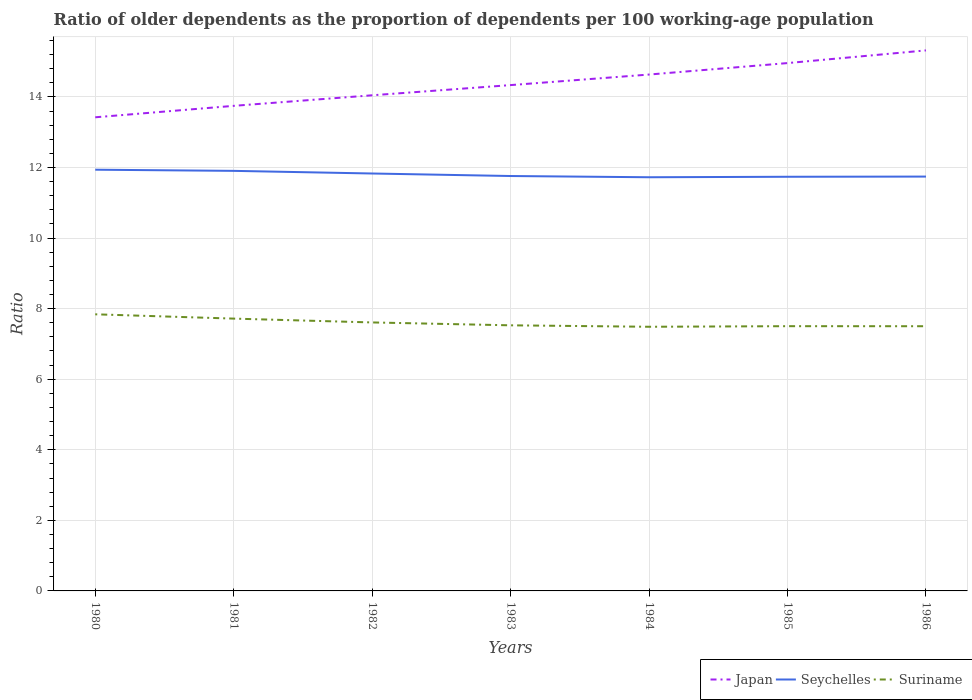Is the number of lines equal to the number of legend labels?
Offer a terse response. Yes. Across all years, what is the maximum age dependency ratio(old) in Japan?
Offer a terse response. 13.42. In which year was the age dependency ratio(old) in Seychelles maximum?
Keep it short and to the point. 1984. What is the total age dependency ratio(old) in Japan in the graph?
Offer a very short reply. -0.68. What is the difference between the highest and the second highest age dependency ratio(old) in Suriname?
Offer a very short reply. 0.35. What is the difference between the highest and the lowest age dependency ratio(old) in Seychelles?
Provide a short and direct response. 3. How many lines are there?
Provide a short and direct response. 3. What is the difference between two consecutive major ticks on the Y-axis?
Provide a short and direct response. 2. Does the graph contain any zero values?
Your response must be concise. No. How are the legend labels stacked?
Make the answer very short. Horizontal. What is the title of the graph?
Your answer should be very brief. Ratio of older dependents as the proportion of dependents per 100 working-age population. Does "Micronesia" appear as one of the legend labels in the graph?
Your answer should be compact. No. What is the label or title of the X-axis?
Provide a succinct answer. Years. What is the label or title of the Y-axis?
Your response must be concise. Ratio. What is the Ratio of Japan in 1980?
Make the answer very short. 13.42. What is the Ratio in Seychelles in 1980?
Your answer should be very brief. 11.94. What is the Ratio in Suriname in 1980?
Your answer should be very brief. 7.84. What is the Ratio in Japan in 1981?
Give a very brief answer. 13.75. What is the Ratio of Seychelles in 1981?
Provide a succinct answer. 11.9. What is the Ratio of Suriname in 1981?
Offer a terse response. 7.72. What is the Ratio in Japan in 1982?
Your response must be concise. 14.05. What is the Ratio of Seychelles in 1982?
Ensure brevity in your answer.  11.83. What is the Ratio of Suriname in 1982?
Offer a very short reply. 7.61. What is the Ratio in Japan in 1983?
Keep it short and to the point. 14.33. What is the Ratio of Seychelles in 1983?
Provide a short and direct response. 11.76. What is the Ratio of Suriname in 1983?
Offer a very short reply. 7.53. What is the Ratio in Japan in 1984?
Give a very brief answer. 14.63. What is the Ratio of Seychelles in 1984?
Your answer should be very brief. 11.72. What is the Ratio in Suriname in 1984?
Provide a short and direct response. 7.49. What is the Ratio of Japan in 1985?
Offer a terse response. 14.96. What is the Ratio in Seychelles in 1985?
Provide a short and direct response. 11.74. What is the Ratio of Suriname in 1985?
Provide a short and direct response. 7.5. What is the Ratio of Japan in 1986?
Offer a terse response. 15.32. What is the Ratio in Seychelles in 1986?
Your response must be concise. 11.74. What is the Ratio of Suriname in 1986?
Offer a very short reply. 7.5. Across all years, what is the maximum Ratio in Japan?
Your answer should be compact. 15.32. Across all years, what is the maximum Ratio of Seychelles?
Give a very brief answer. 11.94. Across all years, what is the maximum Ratio of Suriname?
Keep it short and to the point. 7.84. Across all years, what is the minimum Ratio of Japan?
Your response must be concise. 13.42. Across all years, what is the minimum Ratio in Seychelles?
Provide a succinct answer. 11.72. Across all years, what is the minimum Ratio of Suriname?
Your answer should be compact. 7.49. What is the total Ratio in Japan in the graph?
Give a very brief answer. 100.46. What is the total Ratio of Seychelles in the graph?
Provide a short and direct response. 82.63. What is the total Ratio in Suriname in the graph?
Offer a very short reply. 53.18. What is the difference between the Ratio of Japan in 1980 and that in 1981?
Provide a short and direct response. -0.32. What is the difference between the Ratio in Seychelles in 1980 and that in 1981?
Your response must be concise. 0.03. What is the difference between the Ratio in Suriname in 1980 and that in 1981?
Provide a short and direct response. 0.12. What is the difference between the Ratio of Japan in 1980 and that in 1982?
Your answer should be compact. -0.62. What is the difference between the Ratio of Seychelles in 1980 and that in 1982?
Your answer should be compact. 0.11. What is the difference between the Ratio of Suriname in 1980 and that in 1982?
Your answer should be very brief. 0.23. What is the difference between the Ratio of Japan in 1980 and that in 1983?
Ensure brevity in your answer.  -0.91. What is the difference between the Ratio in Seychelles in 1980 and that in 1983?
Provide a short and direct response. 0.18. What is the difference between the Ratio of Suriname in 1980 and that in 1983?
Offer a terse response. 0.31. What is the difference between the Ratio of Japan in 1980 and that in 1984?
Your response must be concise. -1.21. What is the difference between the Ratio of Seychelles in 1980 and that in 1984?
Provide a short and direct response. 0.21. What is the difference between the Ratio of Suriname in 1980 and that in 1984?
Provide a short and direct response. 0.35. What is the difference between the Ratio in Japan in 1980 and that in 1985?
Make the answer very short. -1.54. What is the difference between the Ratio of Suriname in 1980 and that in 1985?
Your answer should be compact. 0.34. What is the difference between the Ratio in Japan in 1980 and that in 1986?
Offer a terse response. -1.9. What is the difference between the Ratio of Seychelles in 1980 and that in 1986?
Provide a succinct answer. 0.19. What is the difference between the Ratio of Suriname in 1980 and that in 1986?
Offer a terse response. 0.34. What is the difference between the Ratio in Japan in 1981 and that in 1982?
Your response must be concise. -0.3. What is the difference between the Ratio of Seychelles in 1981 and that in 1982?
Offer a terse response. 0.07. What is the difference between the Ratio of Suriname in 1981 and that in 1982?
Provide a short and direct response. 0.11. What is the difference between the Ratio in Japan in 1981 and that in 1983?
Your answer should be very brief. -0.59. What is the difference between the Ratio in Seychelles in 1981 and that in 1983?
Offer a very short reply. 0.15. What is the difference between the Ratio of Suriname in 1981 and that in 1983?
Ensure brevity in your answer.  0.19. What is the difference between the Ratio of Japan in 1981 and that in 1984?
Provide a short and direct response. -0.89. What is the difference between the Ratio of Seychelles in 1981 and that in 1984?
Ensure brevity in your answer.  0.18. What is the difference between the Ratio in Suriname in 1981 and that in 1984?
Offer a terse response. 0.23. What is the difference between the Ratio of Japan in 1981 and that in 1985?
Give a very brief answer. -1.21. What is the difference between the Ratio in Seychelles in 1981 and that in 1985?
Keep it short and to the point. 0.17. What is the difference between the Ratio of Suriname in 1981 and that in 1985?
Provide a succinct answer. 0.21. What is the difference between the Ratio of Japan in 1981 and that in 1986?
Give a very brief answer. -1.57. What is the difference between the Ratio of Seychelles in 1981 and that in 1986?
Your answer should be compact. 0.16. What is the difference between the Ratio in Suriname in 1981 and that in 1986?
Your answer should be very brief. 0.22. What is the difference between the Ratio of Japan in 1982 and that in 1983?
Your answer should be compact. -0.29. What is the difference between the Ratio of Seychelles in 1982 and that in 1983?
Offer a terse response. 0.07. What is the difference between the Ratio of Suriname in 1982 and that in 1983?
Offer a very short reply. 0.08. What is the difference between the Ratio in Japan in 1982 and that in 1984?
Your answer should be compact. -0.59. What is the difference between the Ratio in Seychelles in 1982 and that in 1984?
Your response must be concise. 0.11. What is the difference between the Ratio of Suriname in 1982 and that in 1984?
Give a very brief answer. 0.12. What is the difference between the Ratio in Japan in 1982 and that in 1985?
Your response must be concise. -0.91. What is the difference between the Ratio in Seychelles in 1982 and that in 1985?
Provide a succinct answer. 0.09. What is the difference between the Ratio of Suriname in 1982 and that in 1985?
Provide a succinct answer. 0.11. What is the difference between the Ratio of Japan in 1982 and that in 1986?
Your answer should be compact. -1.27. What is the difference between the Ratio in Seychelles in 1982 and that in 1986?
Your answer should be very brief. 0.09. What is the difference between the Ratio of Suriname in 1982 and that in 1986?
Offer a very short reply. 0.11. What is the difference between the Ratio of Japan in 1983 and that in 1984?
Keep it short and to the point. -0.3. What is the difference between the Ratio of Seychelles in 1983 and that in 1984?
Provide a short and direct response. 0.03. What is the difference between the Ratio in Suriname in 1983 and that in 1984?
Keep it short and to the point. 0.04. What is the difference between the Ratio in Japan in 1983 and that in 1985?
Your answer should be compact. -0.62. What is the difference between the Ratio of Seychelles in 1983 and that in 1985?
Your response must be concise. 0.02. What is the difference between the Ratio in Suriname in 1983 and that in 1985?
Give a very brief answer. 0.02. What is the difference between the Ratio of Japan in 1983 and that in 1986?
Your answer should be very brief. -0.98. What is the difference between the Ratio in Seychelles in 1983 and that in 1986?
Your response must be concise. 0.02. What is the difference between the Ratio in Suriname in 1983 and that in 1986?
Keep it short and to the point. 0.03. What is the difference between the Ratio in Japan in 1984 and that in 1985?
Give a very brief answer. -0.32. What is the difference between the Ratio in Seychelles in 1984 and that in 1985?
Offer a very short reply. -0.01. What is the difference between the Ratio of Suriname in 1984 and that in 1985?
Your answer should be compact. -0.02. What is the difference between the Ratio in Japan in 1984 and that in 1986?
Give a very brief answer. -0.68. What is the difference between the Ratio in Seychelles in 1984 and that in 1986?
Keep it short and to the point. -0.02. What is the difference between the Ratio in Suriname in 1984 and that in 1986?
Provide a short and direct response. -0.02. What is the difference between the Ratio of Japan in 1985 and that in 1986?
Give a very brief answer. -0.36. What is the difference between the Ratio of Seychelles in 1985 and that in 1986?
Provide a succinct answer. -0.01. What is the difference between the Ratio of Suriname in 1985 and that in 1986?
Your answer should be very brief. 0. What is the difference between the Ratio in Japan in 1980 and the Ratio in Seychelles in 1981?
Provide a succinct answer. 1.52. What is the difference between the Ratio in Japan in 1980 and the Ratio in Suriname in 1981?
Your answer should be very brief. 5.71. What is the difference between the Ratio in Seychelles in 1980 and the Ratio in Suriname in 1981?
Your answer should be compact. 4.22. What is the difference between the Ratio in Japan in 1980 and the Ratio in Seychelles in 1982?
Your response must be concise. 1.59. What is the difference between the Ratio of Japan in 1980 and the Ratio of Suriname in 1982?
Provide a short and direct response. 5.81. What is the difference between the Ratio in Seychelles in 1980 and the Ratio in Suriname in 1982?
Your response must be concise. 4.33. What is the difference between the Ratio in Japan in 1980 and the Ratio in Seychelles in 1983?
Keep it short and to the point. 1.66. What is the difference between the Ratio of Japan in 1980 and the Ratio of Suriname in 1983?
Keep it short and to the point. 5.9. What is the difference between the Ratio of Seychelles in 1980 and the Ratio of Suriname in 1983?
Offer a very short reply. 4.41. What is the difference between the Ratio of Japan in 1980 and the Ratio of Seychelles in 1984?
Provide a succinct answer. 1.7. What is the difference between the Ratio of Japan in 1980 and the Ratio of Suriname in 1984?
Offer a very short reply. 5.94. What is the difference between the Ratio in Seychelles in 1980 and the Ratio in Suriname in 1984?
Provide a succinct answer. 4.45. What is the difference between the Ratio in Japan in 1980 and the Ratio in Seychelles in 1985?
Give a very brief answer. 1.69. What is the difference between the Ratio of Japan in 1980 and the Ratio of Suriname in 1985?
Your answer should be compact. 5.92. What is the difference between the Ratio in Seychelles in 1980 and the Ratio in Suriname in 1985?
Offer a terse response. 4.43. What is the difference between the Ratio of Japan in 1980 and the Ratio of Seychelles in 1986?
Offer a very short reply. 1.68. What is the difference between the Ratio in Japan in 1980 and the Ratio in Suriname in 1986?
Your answer should be compact. 5.92. What is the difference between the Ratio of Seychelles in 1980 and the Ratio of Suriname in 1986?
Provide a short and direct response. 4.44. What is the difference between the Ratio of Japan in 1981 and the Ratio of Seychelles in 1982?
Ensure brevity in your answer.  1.92. What is the difference between the Ratio in Japan in 1981 and the Ratio in Suriname in 1982?
Offer a terse response. 6.14. What is the difference between the Ratio of Seychelles in 1981 and the Ratio of Suriname in 1982?
Your response must be concise. 4.3. What is the difference between the Ratio of Japan in 1981 and the Ratio of Seychelles in 1983?
Your answer should be very brief. 1.99. What is the difference between the Ratio of Japan in 1981 and the Ratio of Suriname in 1983?
Ensure brevity in your answer.  6.22. What is the difference between the Ratio in Seychelles in 1981 and the Ratio in Suriname in 1983?
Provide a short and direct response. 4.38. What is the difference between the Ratio in Japan in 1981 and the Ratio in Seychelles in 1984?
Provide a short and direct response. 2.02. What is the difference between the Ratio of Japan in 1981 and the Ratio of Suriname in 1984?
Provide a succinct answer. 6.26. What is the difference between the Ratio of Seychelles in 1981 and the Ratio of Suriname in 1984?
Make the answer very short. 4.42. What is the difference between the Ratio in Japan in 1981 and the Ratio in Seychelles in 1985?
Your response must be concise. 2.01. What is the difference between the Ratio in Japan in 1981 and the Ratio in Suriname in 1985?
Offer a terse response. 6.24. What is the difference between the Ratio of Seychelles in 1981 and the Ratio of Suriname in 1985?
Ensure brevity in your answer.  4.4. What is the difference between the Ratio in Japan in 1981 and the Ratio in Seychelles in 1986?
Provide a short and direct response. 2. What is the difference between the Ratio in Japan in 1981 and the Ratio in Suriname in 1986?
Your answer should be very brief. 6.25. What is the difference between the Ratio of Seychelles in 1981 and the Ratio of Suriname in 1986?
Your response must be concise. 4.4. What is the difference between the Ratio in Japan in 1982 and the Ratio in Seychelles in 1983?
Make the answer very short. 2.29. What is the difference between the Ratio of Japan in 1982 and the Ratio of Suriname in 1983?
Offer a very short reply. 6.52. What is the difference between the Ratio of Seychelles in 1982 and the Ratio of Suriname in 1983?
Provide a short and direct response. 4.3. What is the difference between the Ratio in Japan in 1982 and the Ratio in Seychelles in 1984?
Your answer should be compact. 2.32. What is the difference between the Ratio of Japan in 1982 and the Ratio of Suriname in 1984?
Your answer should be compact. 6.56. What is the difference between the Ratio in Seychelles in 1982 and the Ratio in Suriname in 1984?
Offer a very short reply. 4.34. What is the difference between the Ratio in Japan in 1982 and the Ratio in Seychelles in 1985?
Your answer should be very brief. 2.31. What is the difference between the Ratio in Japan in 1982 and the Ratio in Suriname in 1985?
Provide a short and direct response. 6.54. What is the difference between the Ratio in Seychelles in 1982 and the Ratio in Suriname in 1985?
Provide a succinct answer. 4.33. What is the difference between the Ratio of Japan in 1982 and the Ratio of Seychelles in 1986?
Make the answer very short. 2.3. What is the difference between the Ratio in Japan in 1982 and the Ratio in Suriname in 1986?
Your answer should be very brief. 6.54. What is the difference between the Ratio of Seychelles in 1982 and the Ratio of Suriname in 1986?
Ensure brevity in your answer.  4.33. What is the difference between the Ratio of Japan in 1983 and the Ratio of Seychelles in 1984?
Make the answer very short. 2.61. What is the difference between the Ratio in Japan in 1983 and the Ratio in Suriname in 1984?
Make the answer very short. 6.85. What is the difference between the Ratio of Seychelles in 1983 and the Ratio of Suriname in 1984?
Offer a terse response. 4.27. What is the difference between the Ratio in Japan in 1983 and the Ratio in Seychelles in 1985?
Offer a very short reply. 2.6. What is the difference between the Ratio of Japan in 1983 and the Ratio of Suriname in 1985?
Your answer should be compact. 6.83. What is the difference between the Ratio in Seychelles in 1983 and the Ratio in Suriname in 1985?
Ensure brevity in your answer.  4.26. What is the difference between the Ratio in Japan in 1983 and the Ratio in Seychelles in 1986?
Keep it short and to the point. 2.59. What is the difference between the Ratio in Japan in 1983 and the Ratio in Suriname in 1986?
Offer a very short reply. 6.83. What is the difference between the Ratio in Seychelles in 1983 and the Ratio in Suriname in 1986?
Give a very brief answer. 4.26. What is the difference between the Ratio in Japan in 1984 and the Ratio in Seychelles in 1985?
Make the answer very short. 2.9. What is the difference between the Ratio of Japan in 1984 and the Ratio of Suriname in 1985?
Your answer should be compact. 7.13. What is the difference between the Ratio of Seychelles in 1984 and the Ratio of Suriname in 1985?
Make the answer very short. 4.22. What is the difference between the Ratio in Japan in 1984 and the Ratio in Seychelles in 1986?
Make the answer very short. 2.89. What is the difference between the Ratio in Japan in 1984 and the Ratio in Suriname in 1986?
Offer a terse response. 7.13. What is the difference between the Ratio in Seychelles in 1984 and the Ratio in Suriname in 1986?
Your answer should be compact. 4.22. What is the difference between the Ratio of Japan in 1985 and the Ratio of Seychelles in 1986?
Provide a succinct answer. 3.22. What is the difference between the Ratio of Japan in 1985 and the Ratio of Suriname in 1986?
Make the answer very short. 7.46. What is the difference between the Ratio of Seychelles in 1985 and the Ratio of Suriname in 1986?
Keep it short and to the point. 4.24. What is the average Ratio of Japan per year?
Give a very brief answer. 14.35. What is the average Ratio in Seychelles per year?
Provide a short and direct response. 11.8. What is the average Ratio of Suriname per year?
Give a very brief answer. 7.6. In the year 1980, what is the difference between the Ratio in Japan and Ratio in Seychelles?
Provide a short and direct response. 1.49. In the year 1980, what is the difference between the Ratio of Japan and Ratio of Suriname?
Provide a short and direct response. 5.58. In the year 1980, what is the difference between the Ratio of Seychelles and Ratio of Suriname?
Your response must be concise. 4.1. In the year 1981, what is the difference between the Ratio of Japan and Ratio of Seychelles?
Your response must be concise. 1.84. In the year 1981, what is the difference between the Ratio in Japan and Ratio in Suriname?
Your response must be concise. 6.03. In the year 1981, what is the difference between the Ratio of Seychelles and Ratio of Suriname?
Your answer should be very brief. 4.19. In the year 1982, what is the difference between the Ratio in Japan and Ratio in Seychelles?
Make the answer very short. 2.22. In the year 1982, what is the difference between the Ratio of Japan and Ratio of Suriname?
Offer a very short reply. 6.44. In the year 1982, what is the difference between the Ratio of Seychelles and Ratio of Suriname?
Your answer should be very brief. 4.22. In the year 1983, what is the difference between the Ratio of Japan and Ratio of Seychelles?
Keep it short and to the point. 2.58. In the year 1983, what is the difference between the Ratio in Japan and Ratio in Suriname?
Your answer should be very brief. 6.81. In the year 1983, what is the difference between the Ratio of Seychelles and Ratio of Suriname?
Your response must be concise. 4.23. In the year 1984, what is the difference between the Ratio in Japan and Ratio in Seychelles?
Provide a short and direct response. 2.91. In the year 1984, what is the difference between the Ratio of Japan and Ratio of Suriname?
Ensure brevity in your answer.  7.15. In the year 1984, what is the difference between the Ratio in Seychelles and Ratio in Suriname?
Give a very brief answer. 4.24. In the year 1985, what is the difference between the Ratio in Japan and Ratio in Seychelles?
Ensure brevity in your answer.  3.22. In the year 1985, what is the difference between the Ratio in Japan and Ratio in Suriname?
Offer a terse response. 7.46. In the year 1985, what is the difference between the Ratio of Seychelles and Ratio of Suriname?
Make the answer very short. 4.23. In the year 1986, what is the difference between the Ratio of Japan and Ratio of Seychelles?
Your answer should be compact. 3.58. In the year 1986, what is the difference between the Ratio in Japan and Ratio in Suriname?
Ensure brevity in your answer.  7.82. In the year 1986, what is the difference between the Ratio in Seychelles and Ratio in Suriname?
Your response must be concise. 4.24. What is the ratio of the Ratio in Japan in 1980 to that in 1981?
Provide a short and direct response. 0.98. What is the ratio of the Ratio of Suriname in 1980 to that in 1981?
Offer a very short reply. 1.02. What is the ratio of the Ratio of Japan in 1980 to that in 1982?
Give a very brief answer. 0.96. What is the ratio of the Ratio of Seychelles in 1980 to that in 1982?
Provide a short and direct response. 1.01. What is the ratio of the Ratio of Suriname in 1980 to that in 1982?
Provide a succinct answer. 1.03. What is the ratio of the Ratio in Japan in 1980 to that in 1983?
Ensure brevity in your answer.  0.94. What is the ratio of the Ratio of Seychelles in 1980 to that in 1983?
Offer a terse response. 1.02. What is the ratio of the Ratio in Suriname in 1980 to that in 1983?
Provide a short and direct response. 1.04. What is the ratio of the Ratio in Japan in 1980 to that in 1984?
Your answer should be compact. 0.92. What is the ratio of the Ratio in Seychelles in 1980 to that in 1984?
Provide a short and direct response. 1.02. What is the ratio of the Ratio in Suriname in 1980 to that in 1984?
Your answer should be compact. 1.05. What is the ratio of the Ratio in Japan in 1980 to that in 1985?
Your answer should be very brief. 0.9. What is the ratio of the Ratio of Suriname in 1980 to that in 1985?
Ensure brevity in your answer.  1.04. What is the ratio of the Ratio in Japan in 1980 to that in 1986?
Your response must be concise. 0.88. What is the ratio of the Ratio of Seychelles in 1980 to that in 1986?
Your answer should be compact. 1.02. What is the ratio of the Ratio of Suriname in 1980 to that in 1986?
Make the answer very short. 1.04. What is the ratio of the Ratio of Japan in 1981 to that in 1982?
Offer a terse response. 0.98. What is the ratio of the Ratio of Suriname in 1981 to that in 1982?
Provide a short and direct response. 1.01. What is the ratio of the Ratio of Japan in 1981 to that in 1983?
Your answer should be very brief. 0.96. What is the ratio of the Ratio in Seychelles in 1981 to that in 1983?
Give a very brief answer. 1.01. What is the ratio of the Ratio in Suriname in 1981 to that in 1983?
Offer a terse response. 1.03. What is the ratio of the Ratio of Japan in 1981 to that in 1984?
Keep it short and to the point. 0.94. What is the ratio of the Ratio of Seychelles in 1981 to that in 1984?
Keep it short and to the point. 1.02. What is the ratio of the Ratio of Suriname in 1981 to that in 1984?
Your answer should be very brief. 1.03. What is the ratio of the Ratio in Japan in 1981 to that in 1985?
Ensure brevity in your answer.  0.92. What is the ratio of the Ratio in Seychelles in 1981 to that in 1985?
Your answer should be very brief. 1.01. What is the ratio of the Ratio of Suriname in 1981 to that in 1985?
Your response must be concise. 1.03. What is the ratio of the Ratio in Japan in 1981 to that in 1986?
Provide a short and direct response. 0.9. What is the ratio of the Ratio in Seychelles in 1981 to that in 1986?
Give a very brief answer. 1.01. What is the ratio of the Ratio in Suriname in 1981 to that in 1986?
Your response must be concise. 1.03. What is the ratio of the Ratio in Japan in 1982 to that in 1983?
Give a very brief answer. 0.98. What is the ratio of the Ratio in Seychelles in 1982 to that in 1983?
Ensure brevity in your answer.  1.01. What is the ratio of the Ratio in Suriname in 1982 to that in 1983?
Offer a very short reply. 1.01. What is the ratio of the Ratio of Japan in 1982 to that in 1984?
Offer a very short reply. 0.96. What is the ratio of the Ratio in Seychelles in 1982 to that in 1984?
Provide a short and direct response. 1.01. What is the ratio of the Ratio of Suriname in 1982 to that in 1984?
Ensure brevity in your answer.  1.02. What is the ratio of the Ratio in Japan in 1982 to that in 1985?
Ensure brevity in your answer.  0.94. What is the ratio of the Ratio in Seychelles in 1982 to that in 1985?
Keep it short and to the point. 1.01. What is the ratio of the Ratio in Suriname in 1982 to that in 1985?
Make the answer very short. 1.01. What is the ratio of the Ratio of Japan in 1982 to that in 1986?
Offer a very short reply. 0.92. What is the ratio of the Ratio of Seychelles in 1982 to that in 1986?
Offer a very short reply. 1.01. What is the ratio of the Ratio of Suriname in 1982 to that in 1986?
Give a very brief answer. 1.01. What is the ratio of the Ratio of Japan in 1983 to that in 1984?
Make the answer very short. 0.98. What is the ratio of the Ratio in Seychelles in 1983 to that in 1984?
Give a very brief answer. 1. What is the ratio of the Ratio in Suriname in 1983 to that in 1984?
Give a very brief answer. 1.01. What is the ratio of the Ratio of Japan in 1983 to that in 1985?
Offer a terse response. 0.96. What is the ratio of the Ratio in Suriname in 1983 to that in 1985?
Offer a very short reply. 1. What is the ratio of the Ratio of Japan in 1983 to that in 1986?
Ensure brevity in your answer.  0.94. What is the ratio of the Ratio in Seychelles in 1983 to that in 1986?
Provide a succinct answer. 1. What is the ratio of the Ratio in Suriname in 1983 to that in 1986?
Ensure brevity in your answer.  1. What is the ratio of the Ratio of Japan in 1984 to that in 1985?
Your response must be concise. 0.98. What is the ratio of the Ratio in Seychelles in 1984 to that in 1985?
Offer a terse response. 1. What is the ratio of the Ratio in Japan in 1984 to that in 1986?
Your response must be concise. 0.96. What is the ratio of the Ratio in Seychelles in 1984 to that in 1986?
Your answer should be very brief. 1. What is the ratio of the Ratio of Japan in 1985 to that in 1986?
Provide a succinct answer. 0.98. What is the ratio of the Ratio of Seychelles in 1985 to that in 1986?
Your answer should be very brief. 1. What is the difference between the highest and the second highest Ratio of Japan?
Offer a terse response. 0.36. What is the difference between the highest and the second highest Ratio in Seychelles?
Offer a very short reply. 0.03. What is the difference between the highest and the second highest Ratio of Suriname?
Offer a very short reply. 0.12. What is the difference between the highest and the lowest Ratio in Japan?
Offer a terse response. 1.9. What is the difference between the highest and the lowest Ratio in Seychelles?
Offer a very short reply. 0.21. What is the difference between the highest and the lowest Ratio of Suriname?
Keep it short and to the point. 0.35. 